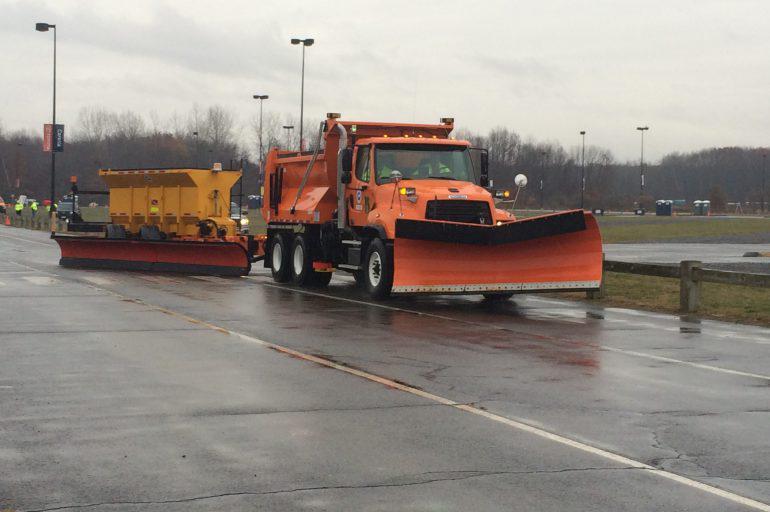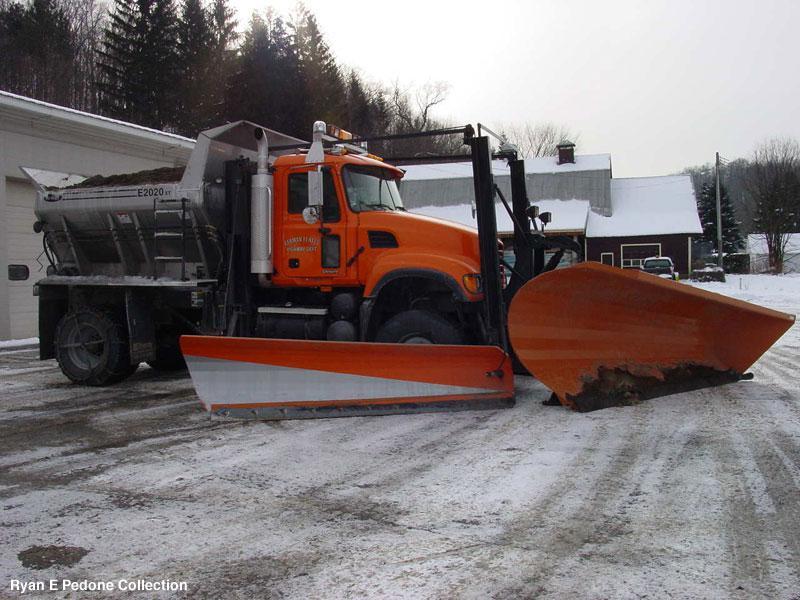The first image is the image on the left, the second image is the image on the right. Evaluate the accuracy of this statement regarding the images: "There is one white vehicle.". Is it true? Answer yes or no. No. The first image is the image on the left, the second image is the image on the right. For the images shown, is this caption "Left image shows one orange truck in front of a yellower piece of equipment." true? Answer yes or no. Yes. 